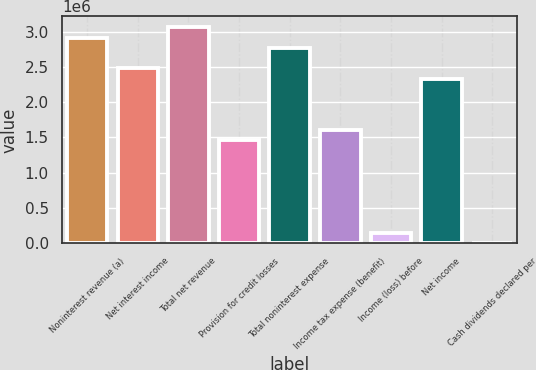Convert chart to OTSL. <chart><loc_0><loc_0><loc_500><loc_500><bar_chart><fcel>Noninterest revenue (a)<fcel>Net interest income<fcel>Total net revenue<fcel>Provision for credit losses<fcel>Total noninterest expense<fcel>Income tax expense (benefit)<fcel>Income (loss) before<fcel>Net income<fcel>Cash dividends declared per<nl><fcel>2.91608e+06<fcel>2.47867e+06<fcel>3.06189e+06<fcel>1.45804e+06<fcel>2.77028e+06<fcel>1.60385e+06<fcel>145805<fcel>2.33287e+06<fcel>0.38<nl></chart> 